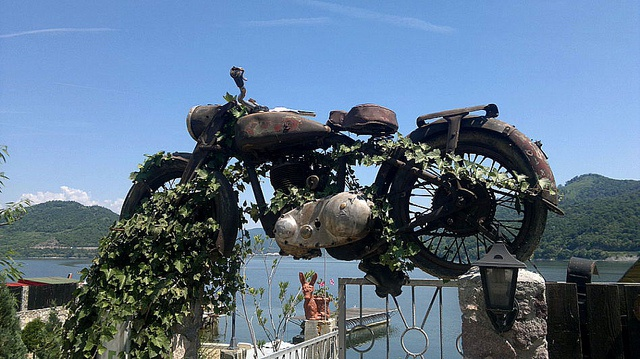Describe the objects in this image and their specific colors. I can see a motorcycle in gray, black, darkgray, and lightgray tones in this image. 